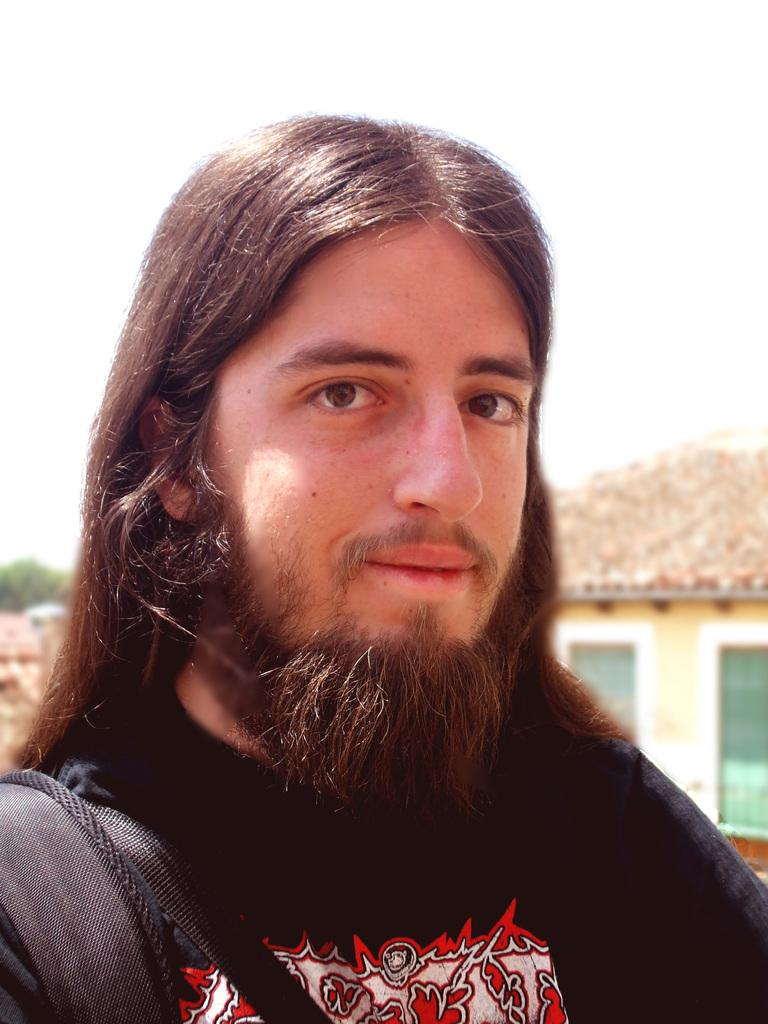What is the main subject of the image? The main subject of the image is a man. Can you describe any specific features of the man? Yes, the man has straps on his left shoulder. What can be seen in the background of the image? There is a building and the sky visible in the background of the image. What type of instrument is the man playing in the image? There is no instrument present in the image, and the man is not playing any instrument. How do the fairies feel about the man's actions in the image? There are no fairies present in the image, so their feelings cannot be determined. 